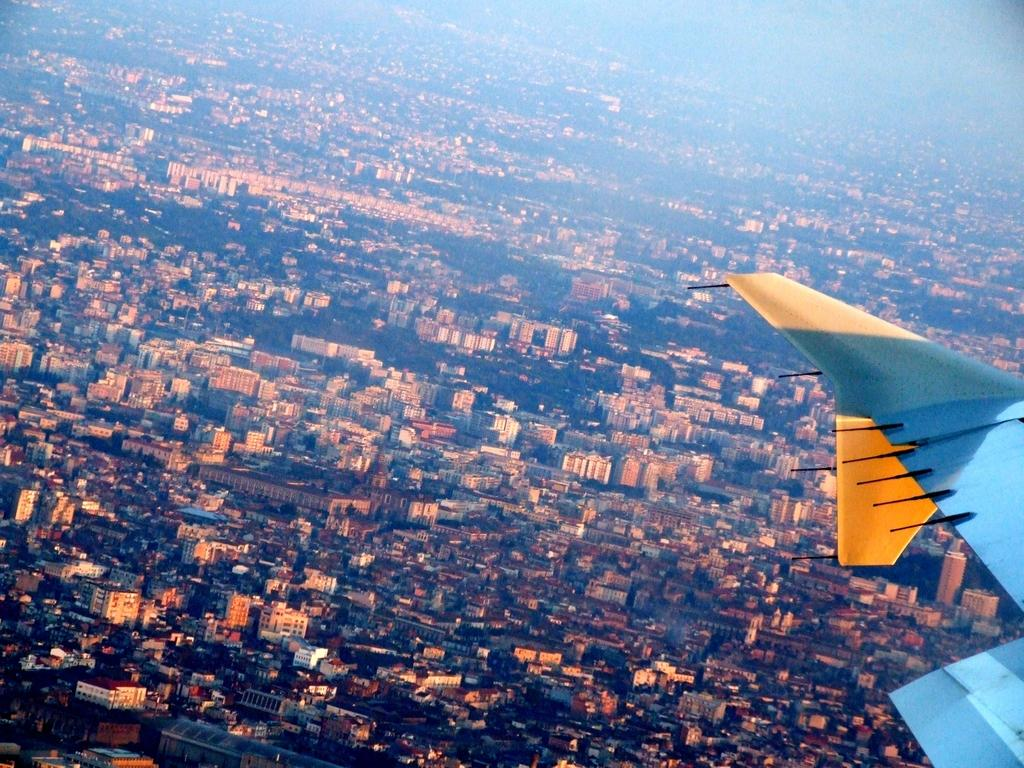What type of view is shown in the image? The image is an aerial view. What structures can be seen from this perspective? There are buildings visible in the image. What natural elements can be seen in the image? There are trees visible in the image. Can you identify any other objects in the image? There appears to be an airplane on the right side of the image. Where is the store located in the image? There is no store present in the image; it features an aerial view of buildings and trees. Can you see any fairies flying among the trees in the image? A: There are no fairies present in the image; it only shows buildings, trees, and an airplane. 